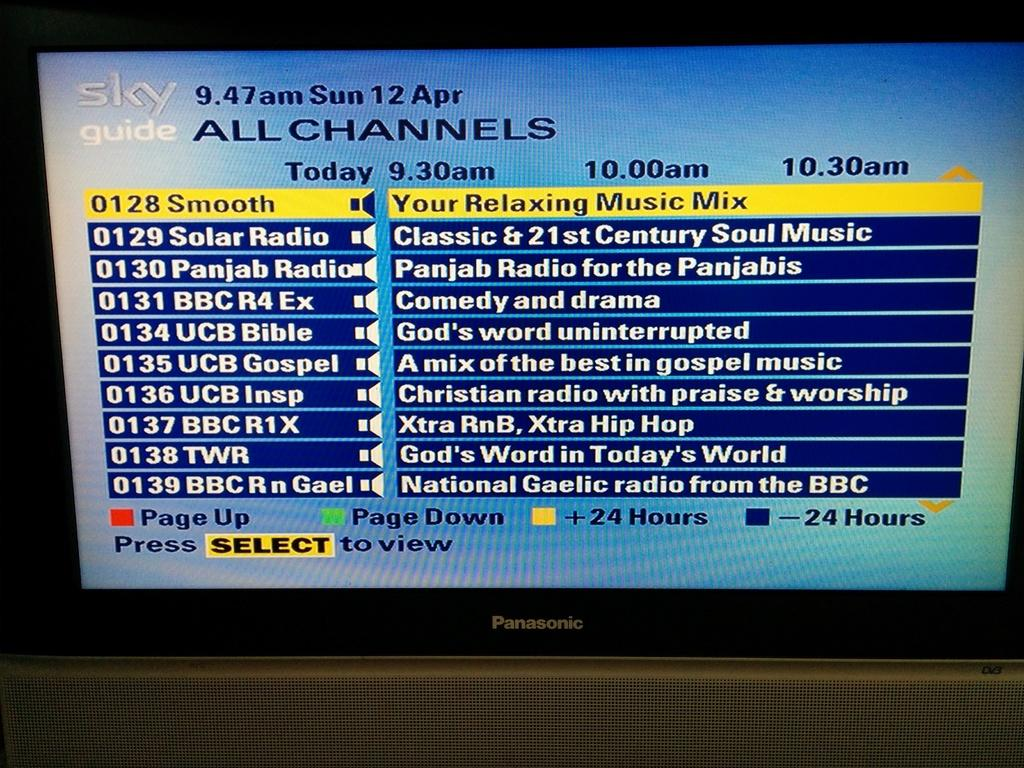<image>
Render a clear and concise summary of the photo. A Panosonic monitor lists various radio stations and what they play. 